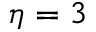<formula> <loc_0><loc_0><loc_500><loc_500>\eta = 3</formula> 